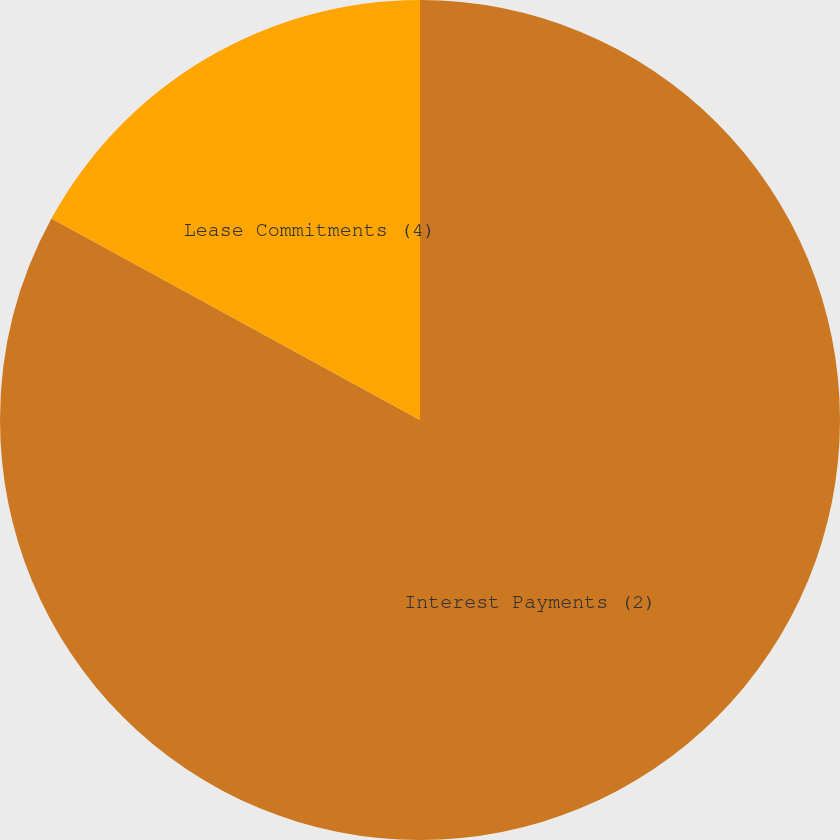<chart> <loc_0><loc_0><loc_500><loc_500><pie_chart><fcel>Interest Payments (2)<fcel>Lease Commitments (4)<nl><fcel>82.96%<fcel>17.04%<nl></chart> 